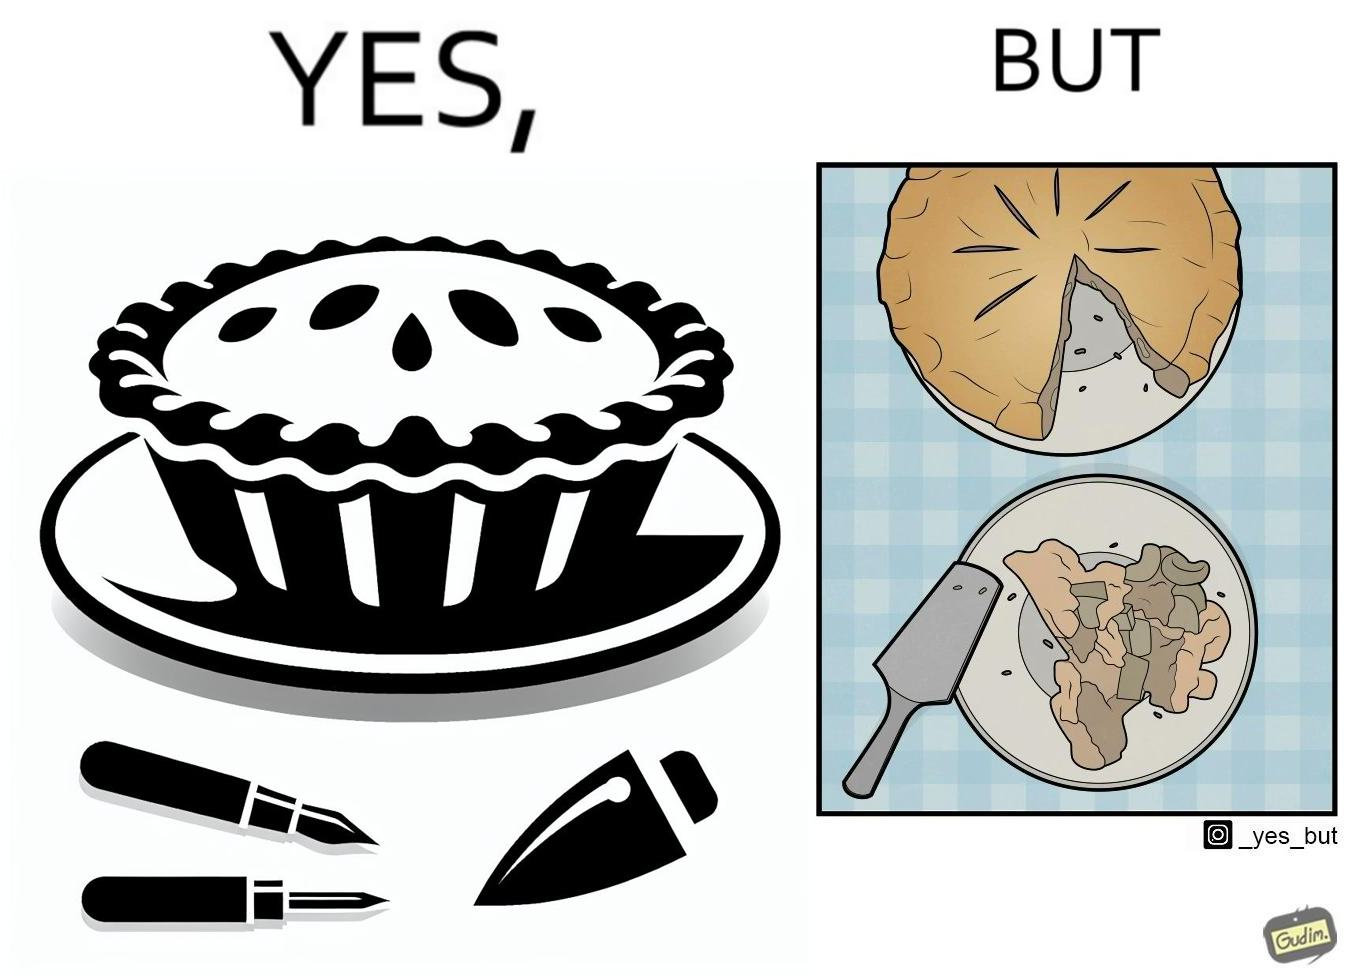Is there satirical content in this image? Yes, this image is satirical. 